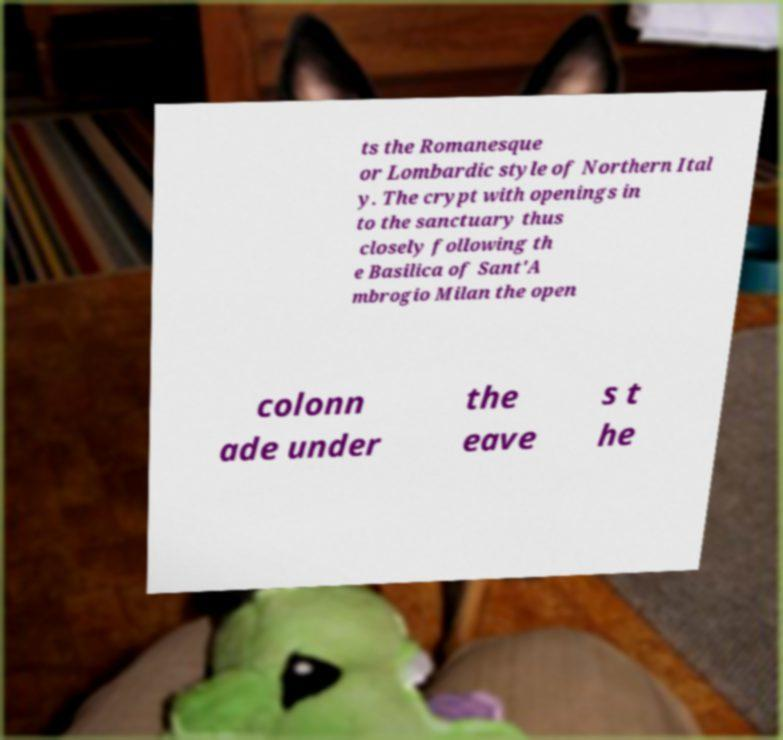Could you assist in decoding the text presented in this image and type it out clearly? ts the Romanesque or Lombardic style of Northern Ital y. The crypt with openings in to the sanctuary thus closely following th e Basilica of Sant'A mbrogio Milan the open colonn ade under the eave s t he 